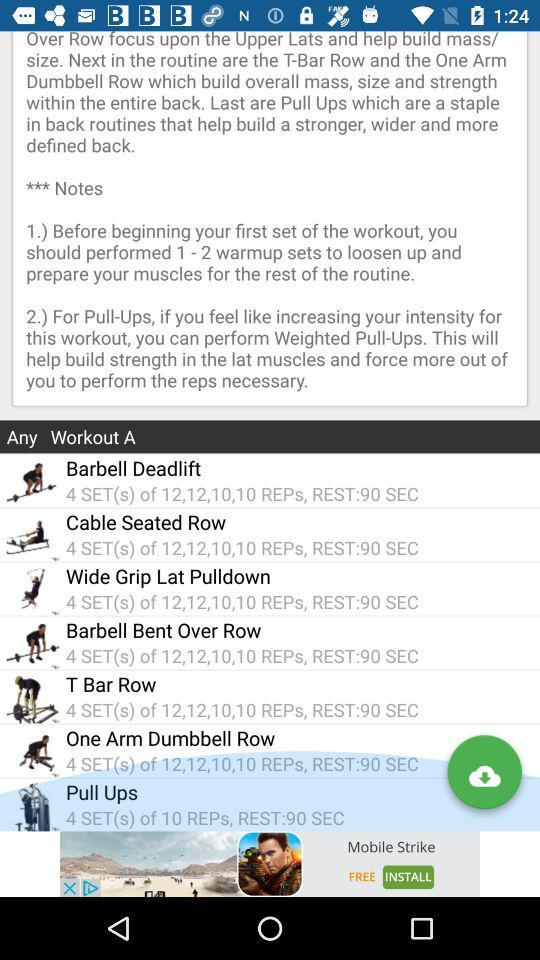Barbell Deadlift has how many sets? Barbell Deadlift has 4 sets. 